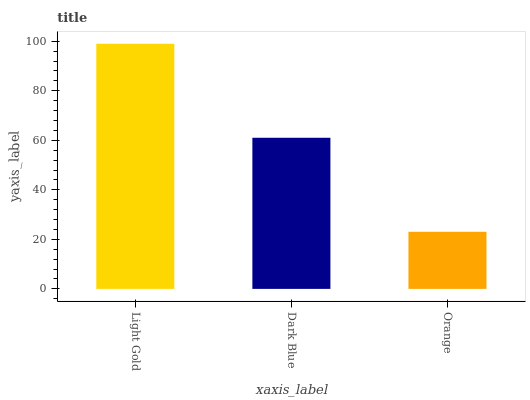Is Orange the minimum?
Answer yes or no. Yes. Is Light Gold the maximum?
Answer yes or no. Yes. Is Dark Blue the minimum?
Answer yes or no. No. Is Dark Blue the maximum?
Answer yes or no. No. Is Light Gold greater than Dark Blue?
Answer yes or no. Yes. Is Dark Blue less than Light Gold?
Answer yes or no. Yes. Is Dark Blue greater than Light Gold?
Answer yes or no. No. Is Light Gold less than Dark Blue?
Answer yes or no. No. Is Dark Blue the high median?
Answer yes or no. Yes. Is Dark Blue the low median?
Answer yes or no. Yes. Is Orange the high median?
Answer yes or no. No. Is Light Gold the low median?
Answer yes or no. No. 